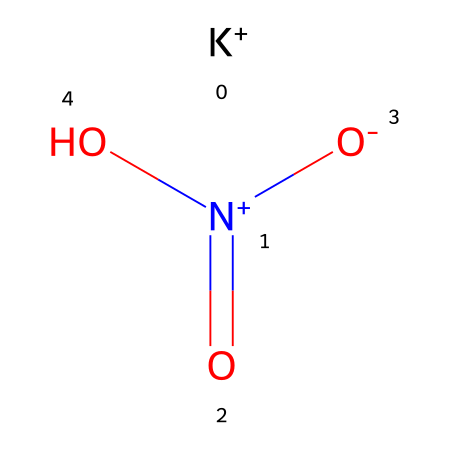What is the name of this chemical? This chemical is commonly known as potassium nitrate. The SMILES representation provides a unique structure indicating its components, where K represents potassium, and the nitrogen and oxygen elements indicate its composition as nitrate.
Answer: potassium nitrate How many nitrogen atoms are present in this compound? In the SMILES representation, there is one nitrogen atom represented by the "N" in the structure. Hence, we can deduce that there is only one nitrogen atom in potassium nitrate.
Answer: 1 What is the oxidation state of nitrogen in potassium nitrate? To determine the oxidation state, we note that potassium (K) has a charge of +1 and the nitrate ion (NO3) has a charge of -1, which requires nitrogen to be in the +5 oxidation state to balance the charges.
Answer: +5 How many oxygen atoms are found in potassium nitrate? The SMILES representation shows three "O" symbols, which correspond to three oxygen atoms in the compound. Thus, we conclude that there are three oxygen atoms present.
Answer: 3 Which element is the cation in this compound? In potassium nitrate, the cation (positively charged ion) is potassium, represented by the "K" in the SMILES. It indicates that potassium is the element that acts as the cation in this ionic compound.
Answer: potassium Is potassium nitrate considered an oxidizer? Yes, potassium nitrate is classified as an oxidizer due to its ability to release oxygen when it decomposes, which can support the combustion of other materials. This characteristic is defined by its composition of nitrate ions.
Answer: yes 